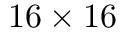<formula> <loc_0><loc_0><loc_500><loc_500>1 6 \times 1 6</formula> 